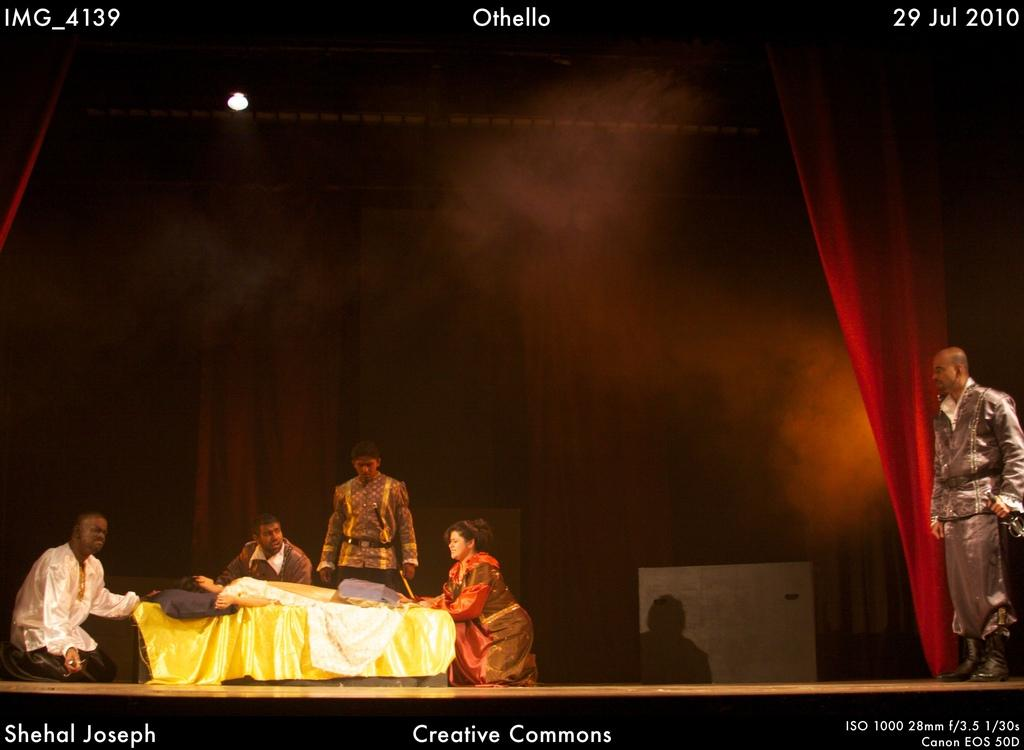What is happening in the image? There are persons performing an act on a stage. Can you describe any text visible in the image? Yes, there is text at the top and bottom of the image. What type of beast can be seen performing a trick with a twig in the image? There is no beast or twig present in the image; it features persons performing an act on a stage. 